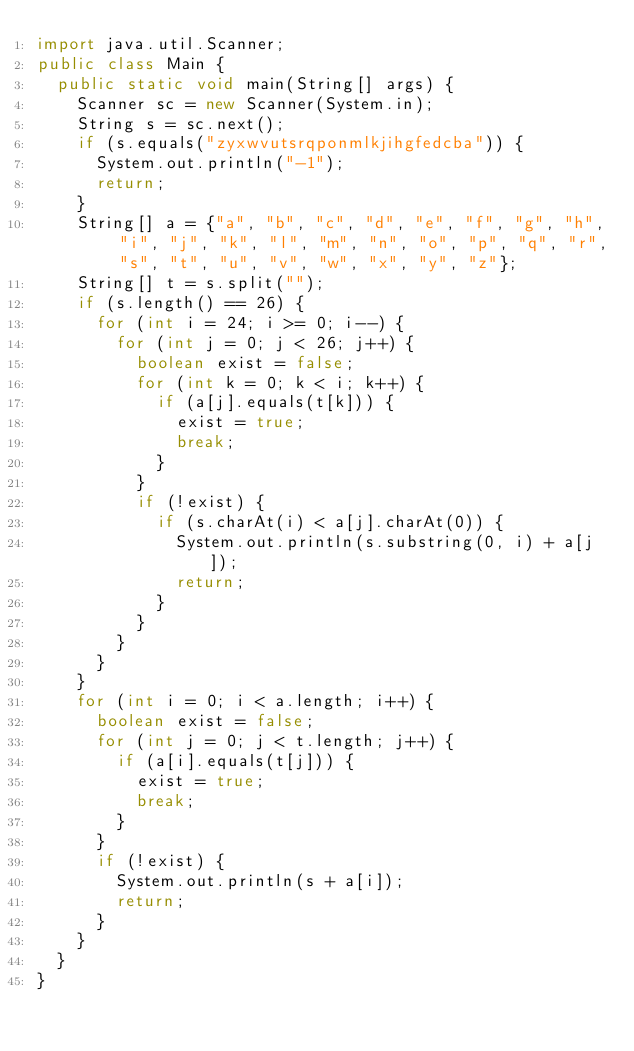<code> <loc_0><loc_0><loc_500><loc_500><_Java_>import java.util.Scanner;
public class Main {
	public static void main(String[] args) {
		Scanner sc = new Scanner(System.in);
		String s = sc.next();
		if (s.equals("zyxwvutsrqponmlkjihgfedcba")) {
			System.out.println("-1");
			return;
		}
		String[] a = {"a", "b", "c", "d", "e", "f", "g", "h", "i", "j", "k", "l", "m", "n", "o", "p", "q", "r", "s", "t", "u", "v", "w", "x", "y", "z"};
		String[] t = s.split("");
		if (s.length() == 26) {
			for (int i = 24; i >= 0; i--) {
				for (int j = 0; j < 26; j++) {
					boolean exist = false;
					for (int k = 0; k < i; k++) {
						if (a[j].equals(t[k])) {
							exist = true;
							break;
						}
					}
					if (!exist) {
						if (s.charAt(i) < a[j].charAt(0)) {
							System.out.println(s.substring(0, i) + a[j]);
							return;
						}
					}
				}
			}
		}
		for (int i = 0; i < a.length; i++) {
			boolean exist = false;
			for (int j = 0; j < t.length; j++) {
				if (a[i].equals(t[j])) {
					exist = true;
					break;
				}
			}
			if (!exist) {
				System.out.println(s + a[i]);
				return;
			}
		}
	}
}</code> 